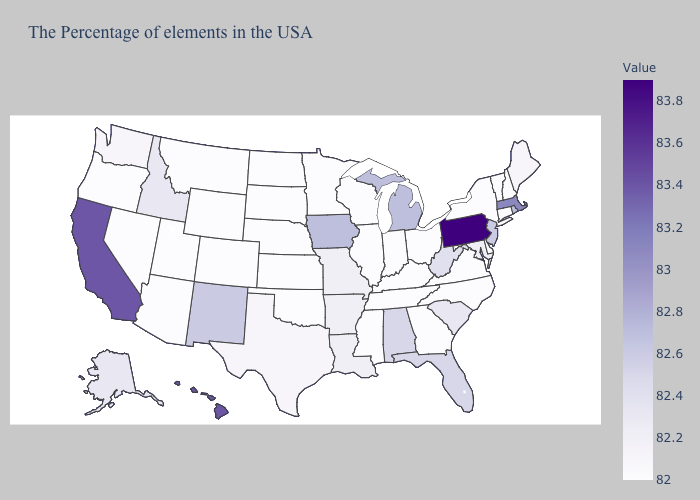Which states have the lowest value in the Northeast?
Be succinct. New Hampshire, Vermont, Connecticut, New York. Does Pennsylvania have the highest value in the USA?
Short answer required. Yes. Does Florida have the highest value in the South?
Answer briefly. Yes. Among the states that border South Dakota , does Iowa have the lowest value?
Short answer required. No. Which states hav the highest value in the West?
Concise answer only. California, Hawaii. Is the legend a continuous bar?
Short answer required. Yes. Which states have the highest value in the USA?
Give a very brief answer. Pennsylvania. Does Michigan have a higher value than Florida?
Keep it brief. Yes. 